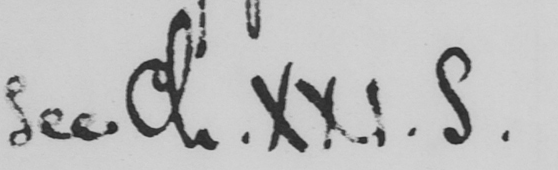Can you read and transcribe this handwriting? see Ch . XXI . S . 